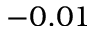Convert formula to latex. <formula><loc_0><loc_0><loc_500><loc_500>- 0 . 0 1</formula> 